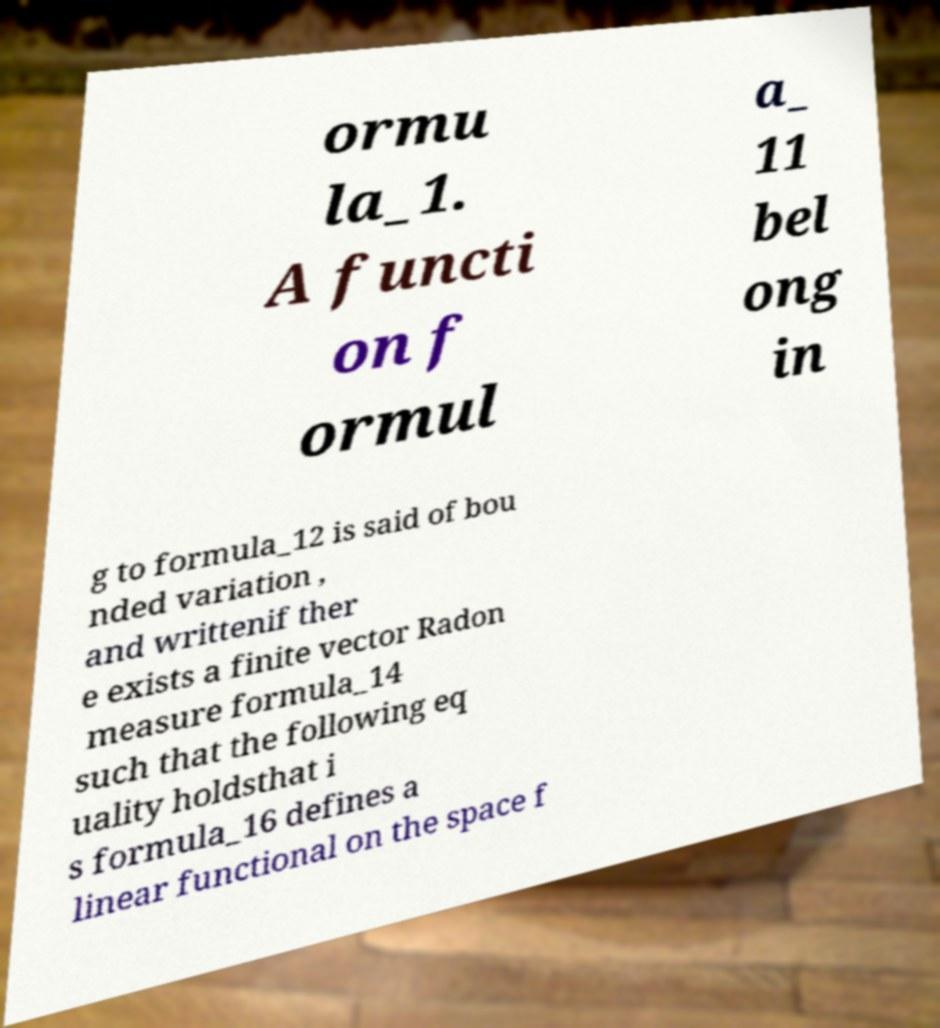Please identify and transcribe the text found in this image. ormu la_1. A functi on f ormul a_ 11 bel ong in g to formula_12 is said of bou nded variation , and writtenif ther e exists a finite vector Radon measure formula_14 such that the following eq uality holdsthat i s formula_16 defines a linear functional on the space f 